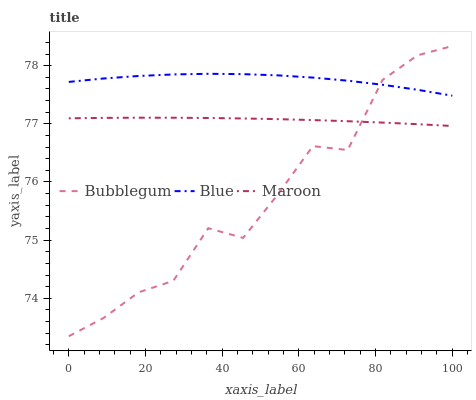Does Bubblegum have the minimum area under the curve?
Answer yes or no. Yes. Does Blue have the maximum area under the curve?
Answer yes or no. Yes. Does Maroon have the minimum area under the curve?
Answer yes or no. No. Does Maroon have the maximum area under the curve?
Answer yes or no. No. Is Maroon the smoothest?
Answer yes or no. Yes. Is Bubblegum the roughest?
Answer yes or no. Yes. Is Bubblegum the smoothest?
Answer yes or no. No. Is Maroon the roughest?
Answer yes or no. No. Does Bubblegum have the lowest value?
Answer yes or no. Yes. Does Maroon have the lowest value?
Answer yes or no. No. Does Bubblegum have the highest value?
Answer yes or no. Yes. Does Maroon have the highest value?
Answer yes or no. No. Is Maroon less than Blue?
Answer yes or no. Yes. Is Blue greater than Maroon?
Answer yes or no. Yes. Does Bubblegum intersect Maroon?
Answer yes or no. Yes. Is Bubblegum less than Maroon?
Answer yes or no. No. Is Bubblegum greater than Maroon?
Answer yes or no. No. Does Maroon intersect Blue?
Answer yes or no. No. 